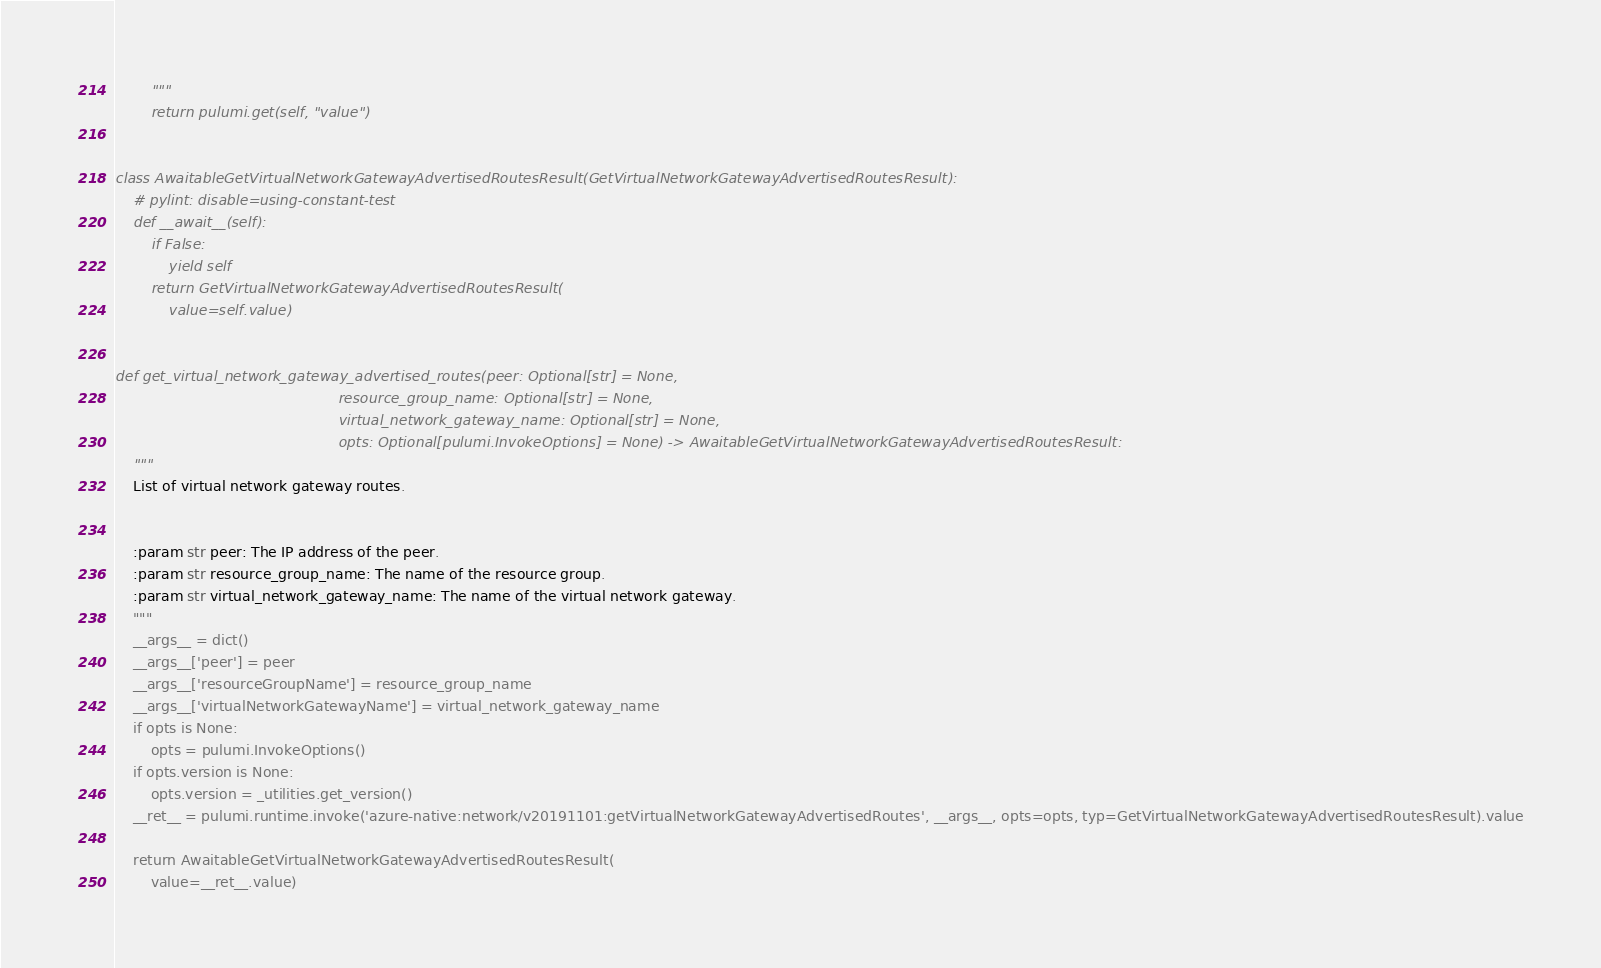<code> <loc_0><loc_0><loc_500><loc_500><_Python_>        """
        return pulumi.get(self, "value")


class AwaitableGetVirtualNetworkGatewayAdvertisedRoutesResult(GetVirtualNetworkGatewayAdvertisedRoutesResult):
    # pylint: disable=using-constant-test
    def __await__(self):
        if False:
            yield self
        return GetVirtualNetworkGatewayAdvertisedRoutesResult(
            value=self.value)


def get_virtual_network_gateway_advertised_routes(peer: Optional[str] = None,
                                                  resource_group_name: Optional[str] = None,
                                                  virtual_network_gateway_name: Optional[str] = None,
                                                  opts: Optional[pulumi.InvokeOptions] = None) -> AwaitableGetVirtualNetworkGatewayAdvertisedRoutesResult:
    """
    List of virtual network gateway routes.


    :param str peer: The IP address of the peer.
    :param str resource_group_name: The name of the resource group.
    :param str virtual_network_gateway_name: The name of the virtual network gateway.
    """
    __args__ = dict()
    __args__['peer'] = peer
    __args__['resourceGroupName'] = resource_group_name
    __args__['virtualNetworkGatewayName'] = virtual_network_gateway_name
    if opts is None:
        opts = pulumi.InvokeOptions()
    if opts.version is None:
        opts.version = _utilities.get_version()
    __ret__ = pulumi.runtime.invoke('azure-native:network/v20191101:getVirtualNetworkGatewayAdvertisedRoutes', __args__, opts=opts, typ=GetVirtualNetworkGatewayAdvertisedRoutesResult).value

    return AwaitableGetVirtualNetworkGatewayAdvertisedRoutesResult(
        value=__ret__.value)
</code> 